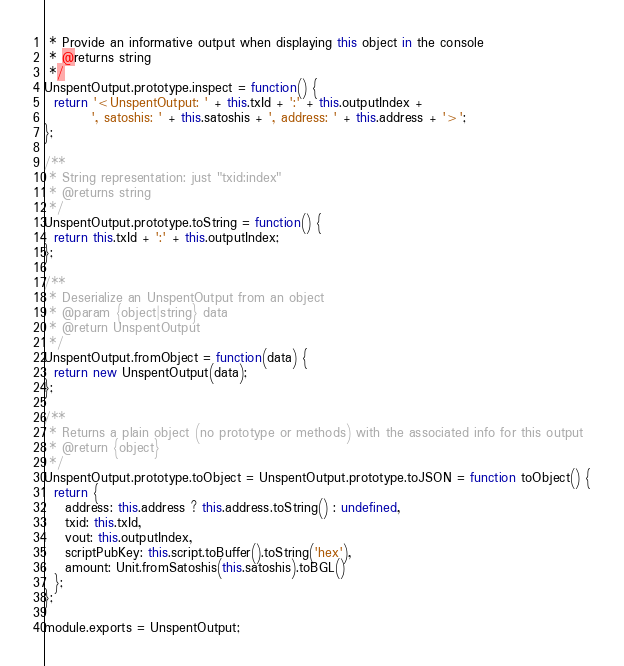Convert code to text. <code><loc_0><loc_0><loc_500><loc_500><_JavaScript_> * Provide an informative output when displaying this object in the console
 * @returns string
 */
UnspentOutput.prototype.inspect = function() {
  return '<UnspentOutput: ' + this.txId + ':' + this.outputIndex +
         ', satoshis: ' + this.satoshis + ', address: ' + this.address + '>';
};

/**
 * String representation: just "txid:index"
 * @returns string
 */
UnspentOutput.prototype.toString = function() {
  return this.txId + ':' + this.outputIndex;
};

/**
 * Deserialize an UnspentOutput from an object
 * @param {object|string} data
 * @return UnspentOutput
 */
UnspentOutput.fromObject = function(data) {
  return new UnspentOutput(data);
};

/**
 * Returns a plain object (no prototype or methods) with the associated info for this output
 * @return {object}
 */
UnspentOutput.prototype.toObject = UnspentOutput.prototype.toJSON = function toObject() {
  return {
    address: this.address ? this.address.toString() : undefined,
    txid: this.txId,
    vout: this.outputIndex,
    scriptPubKey: this.script.toBuffer().toString('hex'),
    amount: Unit.fromSatoshis(this.satoshis).toBGL()
  };
};

module.exports = UnspentOutput;
</code> 